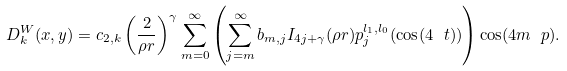<formula> <loc_0><loc_0><loc_500><loc_500>D _ { k } ^ { W } ( x , y ) = c _ { 2 , k } \left ( \frac { 2 } { \rho r } \right ) ^ { \gamma } \sum _ { m = 0 } ^ { \infty } \left ( \sum _ { j = m } ^ { \infty } b _ { m , j } I _ { 4 j + \gamma } ( \rho r ) p _ { j } ^ { l _ { 1 } , l _ { 0 } } ( \cos ( 4 \ t ) ) \right ) \cos ( 4 m \ p ) .</formula> 